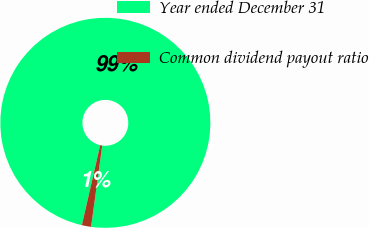Convert chart. <chart><loc_0><loc_0><loc_500><loc_500><pie_chart><fcel>Year ended December 31<fcel>Common dividend payout ratio<nl><fcel>98.58%<fcel>1.42%<nl></chart> 